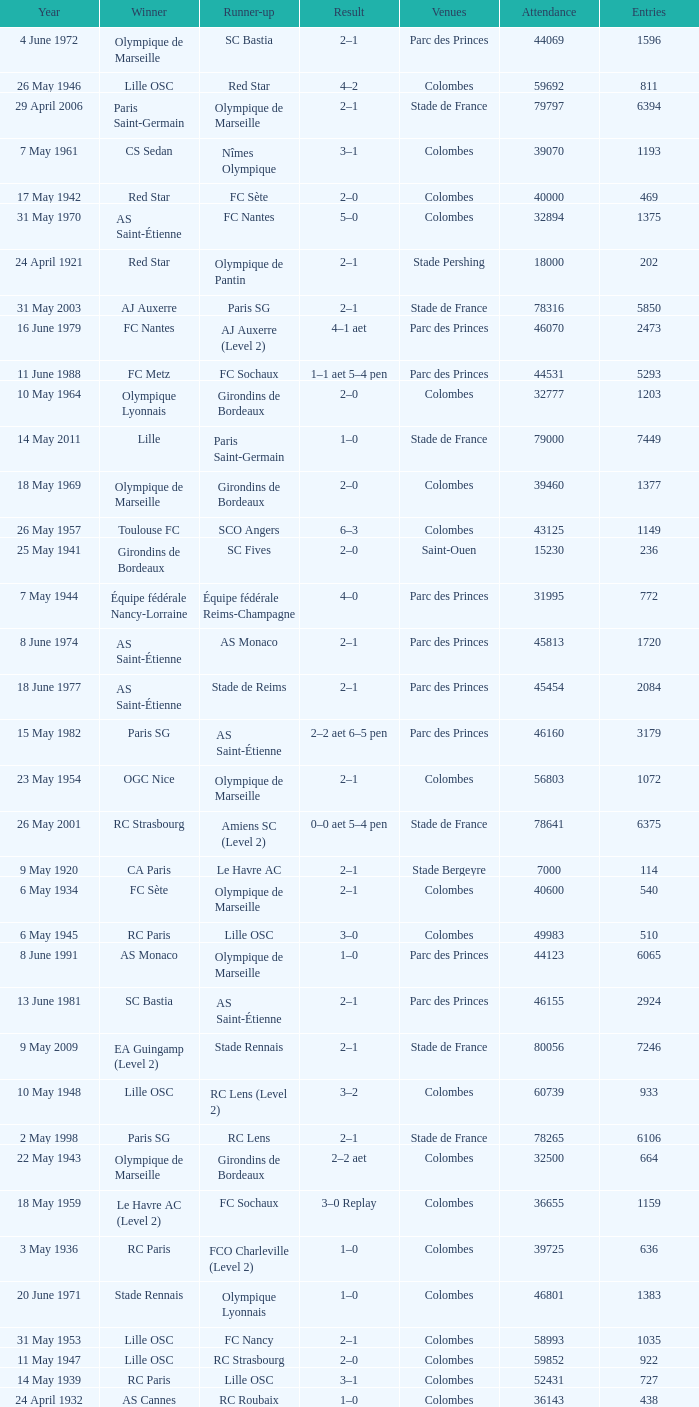What is the fewest recorded entrants against paris saint-germain? 6394.0. 